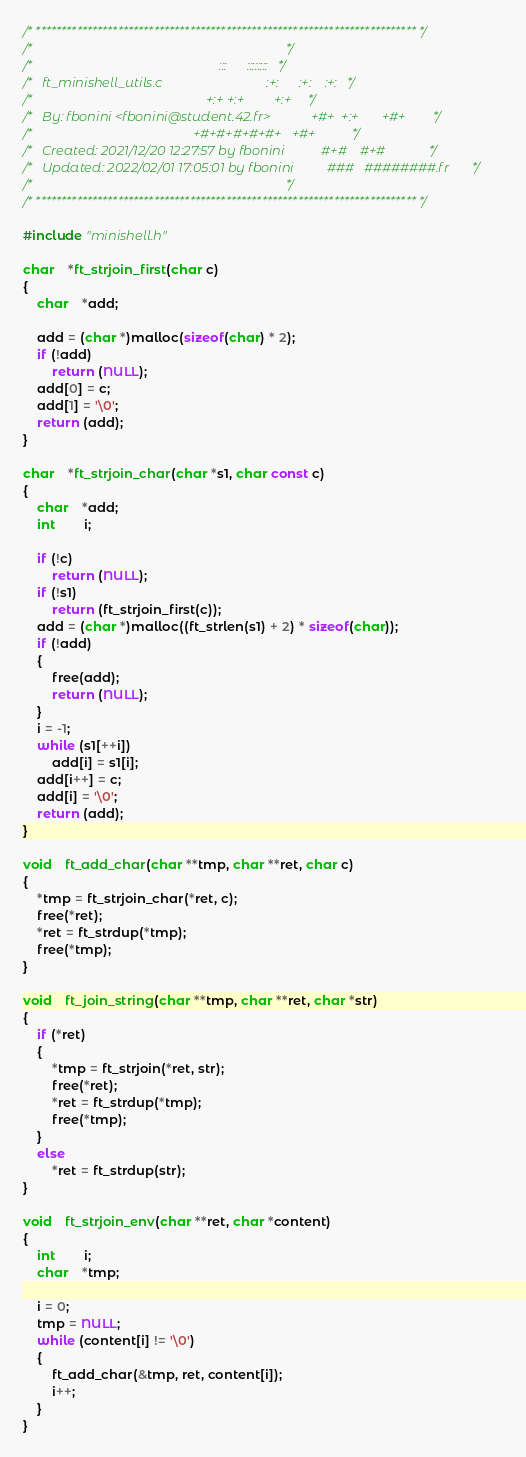Convert code to text. <code><loc_0><loc_0><loc_500><loc_500><_C_>/* ************************************************************************** */
/*                                                                            */
/*                                                        :::      ::::::::   */
/*   ft_minishell_utils.c                               :+:      :+:    :+:   */
/*                                                    +:+ +:+         +:+     */
/*   By: fbonini <fbonini@student.42.fr>            +#+  +:+       +#+        */
/*                                                +#+#+#+#+#+   +#+           */
/*   Created: 2021/12/20 12:27:57 by fbonini           #+#    #+#             */
/*   Updated: 2022/02/01 17:05:01 by fbonini          ###   ########.fr       */
/*                                                                            */
/* ************************************************************************** */

#include "minishell.h"

char	*ft_strjoin_first(char c)
{
	char	*add;

	add = (char *)malloc(sizeof(char) * 2);
	if (!add)
		return (NULL);
	add[0] = c;
	add[1] = '\0';
	return (add);
}

char	*ft_strjoin_char(char *s1, char const c)
{
	char	*add;
	int		i;

	if (!c)
		return (NULL);
	if (!s1)
		return (ft_strjoin_first(c));
	add = (char *)malloc((ft_strlen(s1) + 2) * sizeof(char));
	if (!add)
	{
		free(add);
		return (NULL);
	}
	i = -1;
	while (s1[++i])
		add[i] = s1[i];
	add[i++] = c;
	add[i] = '\0';
	return (add);
}

void	ft_add_char(char **tmp, char **ret, char c)
{
	*tmp = ft_strjoin_char(*ret, c);
	free(*ret);
	*ret = ft_strdup(*tmp);
	free(*tmp);
}

void	ft_join_string(char **tmp, char **ret, char *str)
{
	if (*ret)
	{
		*tmp = ft_strjoin(*ret, str);
		free(*ret);
		*ret = ft_strdup(*tmp);
		free(*tmp);
	}
	else
		*ret = ft_strdup(str);
}

void	ft_strjoin_env(char **ret, char *content)
{
	int		i;
	char	*tmp;

	i = 0;
	tmp = NULL;
	while (content[i] != '\0')
	{
		ft_add_char(&tmp, ret, content[i]);
		i++;
	}
}
</code> 